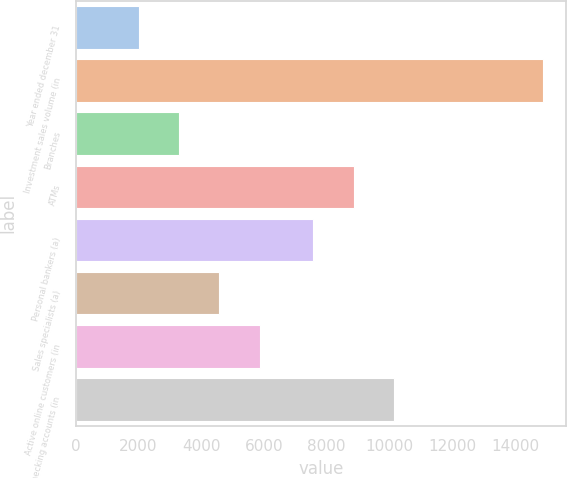<chart> <loc_0><loc_0><loc_500><loc_500><bar_chart><fcel>Year ended december 31<fcel>Investment sales volume (in<fcel>Branches<fcel>ATMs<fcel>Personal bankers (a)<fcel>Sales specialists (a)<fcel>Active online customers (in<fcel>Checking accounts (in<nl><fcel>2006<fcel>14882<fcel>3293.6<fcel>8860.6<fcel>7573<fcel>4581.2<fcel>5868.8<fcel>10148.2<nl></chart> 